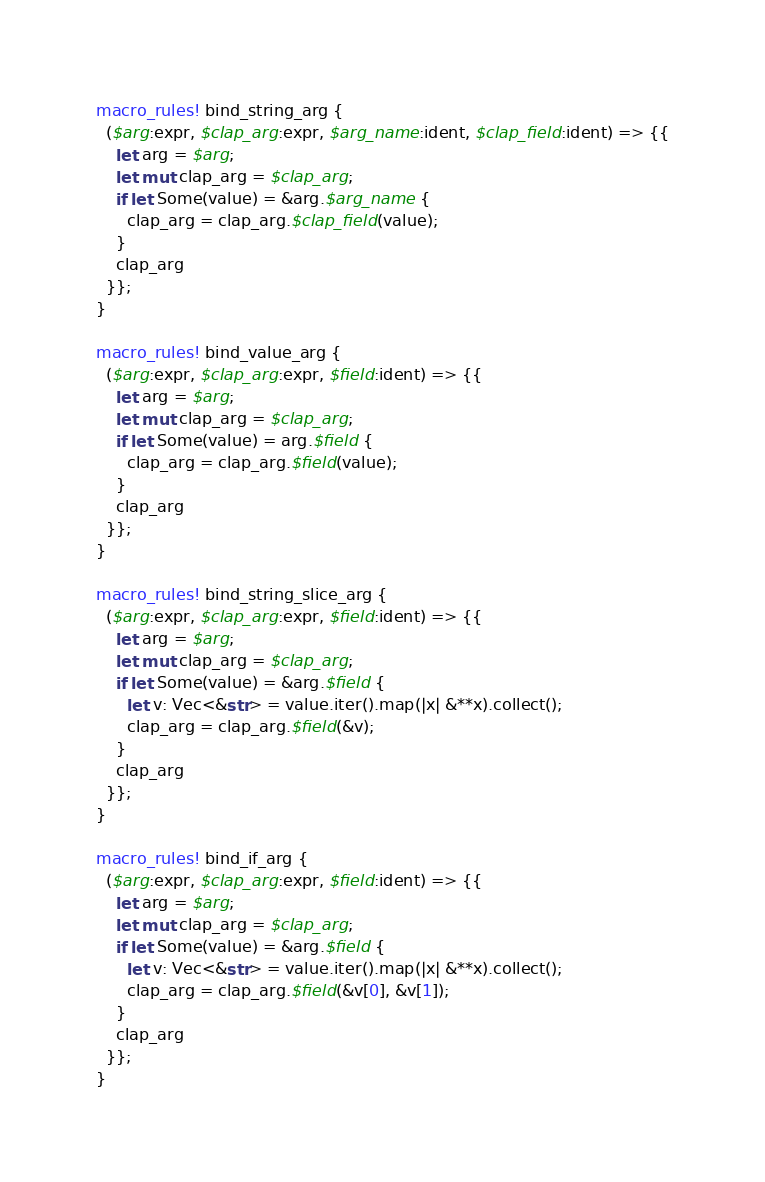<code> <loc_0><loc_0><loc_500><loc_500><_Rust_>macro_rules! bind_string_arg {
  ($arg:expr, $clap_arg:expr, $arg_name:ident, $clap_field:ident) => {{
    let arg = $arg;
    let mut clap_arg = $clap_arg;
    if let Some(value) = &arg.$arg_name {
      clap_arg = clap_arg.$clap_field(value);
    }
    clap_arg
  }};
}

macro_rules! bind_value_arg {
  ($arg:expr, $clap_arg:expr, $field:ident) => {{
    let arg = $arg;
    let mut clap_arg = $clap_arg;
    if let Some(value) = arg.$field {
      clap_arg = clap_arg.$field(value);
    }
    clap_arg
  }};
}

macro_rules! bind_string_slice_arg {
  ($arg:expr, $clap_arg:expr, $field:ident) => {{
    let arg = $arg;
    let mut clap_arg = $clap_arg;
    if let Some(value) = &arg.$field {
      let v: Vec<&str> = value.iter().map(|x| &**x).collect();
      clap_arg = clap_arg.$field(&v);
    }
    clap_arg
  }};
}

macro_rules! bind_if_arg {
  ($arg:expr, $clap_arg:expr, $field:ident) => {{
    let arg = $arg;
    let mut clap_arg = $clap_arg;
    if let Some(value) = &arg.$field {
      let v: Vec<&str> = value.iter().map(|x| &**x).collect();
      clap_arg = clap_arg.$field(&v[0], &v[1]);
    }
    clap_arg
  }};
}
</code> 